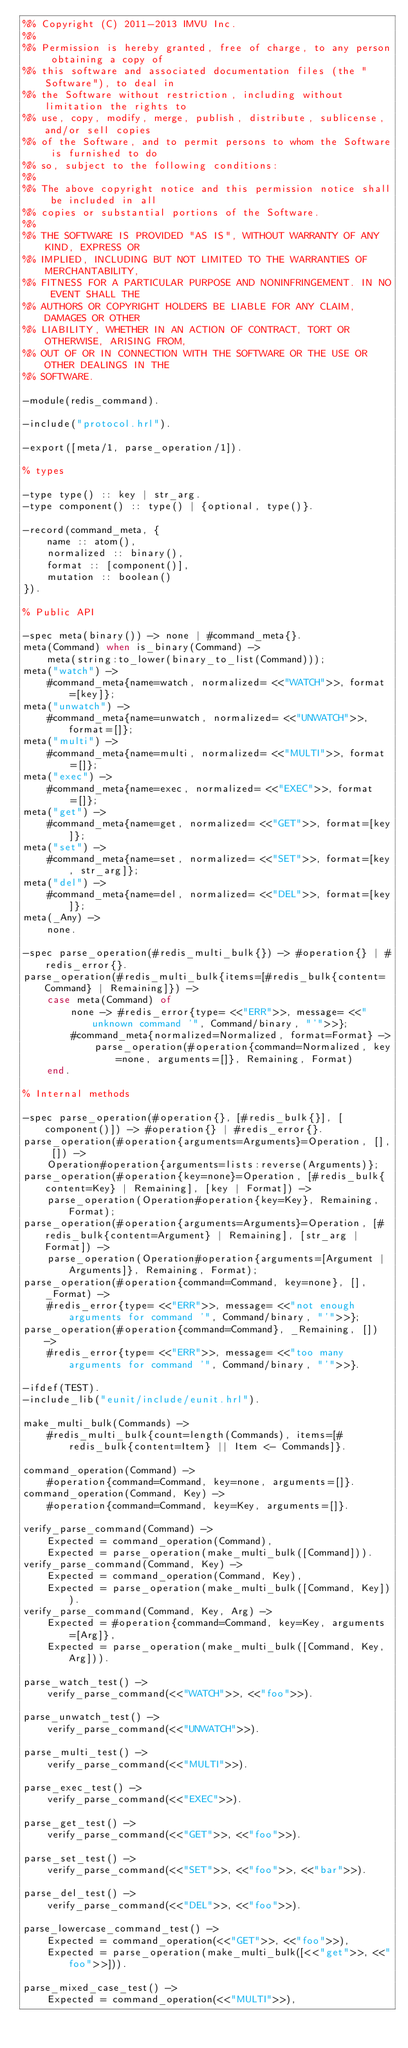Convert code to text. <code><loc_0><loc_0><loc_500><loc_500><_Erlang_>%% Copyright (C) 2011-2013 IMVU Inc.
%%
%% Permission is hereby granted, free of charge, to any person obtaining a copy of
%% this software and associated documentation files (the "Software"), to deal in
%% the Software without restriction, including without limitation the rights to
%% use, copy, modify, merge, publish, distribute, sublicense, and/or sell copies
%% of the Software, and to permit persons to whom the Software is furnished to do
%% so, subject to the following conditions:
%%
%% The above copyright notice and this permission notice shall be included in all
%% copies or substantial portions of the Software.
%%
%% THE SOFTWARE IS PROVIDED "AS IS", WITHOUT WARRANTY OF ANY KIND, EXPRESS OR
%% IMPLIED, INCLUDING BUT NOT LIMITED TO THE WARRANTIES OF MERCHANTABILITY,
%% FITNESS FOR A PARTICULAR PURPOSE AND NONINFRINGEMENT. IN NO EVENT SHALL THE
%% AUTHORS OR COPYRIGHT HOLDERS BE LIABLE FOR ANY CLAIM, DAMAGES OR OTHER
%% LIABILITY, WHETHER IN AN ACTION OF CONTRACT, TORT OR OTHERWISE, ARISING FROM,
%% OUT OF OR IN CONNECTION WITH THE SOFTWARE OR THE USE OR OTHER DEALINGS IN THE
%% SOFTWARE.

-module(redis_command).

-include("protocol.hrl").

-export([meta/1, parse_operation/1]).

% types

-type type() :: key | str_arg.
-type component() :: type() | {optional, type()}.

-record(command_meta, {
    name :: atom(),
    normalized :: binary(),
    format :: [component()],
    mutation :: boolean()
}).

% Public API

-spec meta(binary()) -> none | #command_meta{}.
meta(Command) when is_binary(Command) ->
    meta(string:to_lower(binary_to_list(Command)));
meta("watch") ->
    #command_meta{name=watch, normalized= <<"WATCH">>, format=[key]};
meta("unwatch") ->
    #command_meta{name=unwatch, normalized= <<"UNWATCH">>, format=[]};
meta("multi") ->
    #command_meta{name=multi, normalized= <<"MULTI">>, format=[]};
meta("exec") ->
    #command_meta{name=exec, normalized= <<"EXEC">>, format=[]};
meta("get") ->
    #command_meta{name=get, normalized= <<"GET">>, format=[key]};
meta("set") ->
    #command_meta{name=set, normalized= <<"SET">>, format=[key, str_arg]};
meta("del") ->
    #command_meta{name=del, normalized= <<"DEL">>, format=[key]};
meta(_Any) ->
    none.

-spec parse_operation(#redis_multi_bulk{}) -> #operation{} | #redis_error{}.
parse_operation(#redis_multi_bulk{items=[#redis_bulk{content=Command} | Remaining]}) ->
    case meta(Command) of
        none -> #redis_error{type= <<"ERR">>, message= <<"unknown command '", Command/binary, "'">>};
        #command_meta{normalized=Normalized, format=Format} ->
            parse_operation(#operation{command=Normalized, key=none, arguments=[]}, Remaining, Format)
    end.

% Internal methods

-spec parse_operation(#operation{}, [#redis_bulk{}], [component()]) -> #operation{} | #redis_error{}.
parse_operation(#operation{arguments=Arguments}=Operation, [], []) ->
    Operation#operation{arguments=lists:reverse(Arguments)};
parse_operation(#operation{key=none}=Operation, [#redis_bulk{content=Key} | Remaining], [key | Format]) ->
    parse_operation(Operation#operation{key=Key}, Remaining, Format);
parse_operation(#operation{arguments=Arguments}=Operation, [#redis_bulk{content=Argument} | Remaining], [str_arg | Format]) ->
    parse_operation(Operation#operation{arguments=[Argument | Arguments]}, Remaining, Format);
parse_operation(#operation{command=Command, key=none}, [], _Format) ->
    #redis_error{type= <<"ERR">>, message= <<"not enough arguments for command '", Command/binary, "'">>};
parse_operation(#operation{command=Command}, _Remaining, []) ->
    #redis_error{type= <<"ERR">>, message= <<"too many arguments for command '", Command/binary, "'">>}.

-ifdef(TEST).
-include_lib("eunit/include/eunit.hrl").

make_multi_bulk(Commands) ->
    #redis_multi_bulk{count=length(Commands), items=[#redis_bulk{content=Item} || Item <- Commands]}.

command_operation(Command) ->
    #operation{command=Command, key=none, arguments=[]}.
command_operation(Command, Key) ->
    #operation{command=Command, key=Key, arguments=[]}.

verify_parse_command(Command) ->
    Expected = command_operation(Command),
    Expected = parse_operation(make_multi_bulk([Command])).
verify_parse_command(Command, Key) ->
    Expected = command_operation(Command, Key),
    Expected = parse_operation(make_multi_bulk([Command, Key])).
verify_parse_command(Command, Key, Arg) ->
    Expected = #operation{command=Command, key=Key, arguments=[Arg]},
    Expected = parse_operation(make_multi_bulk([Command, Key, Arg])).

parse_watch_test() ->
    verify_parse_command(<<"WATCH">>, <<"foo">>).

parse_unwatch_test() ->
    verify_parse_command(<<"UNWATCH">>).

parse_multi_test() ->
    verify_parse_command(<<"MULTI">>).

parse_exec_test() ->
    verify_parse_command(<<"EXEC">>).

parse_get_test() ->
    verify_parse_command(<<"GET">>, <<"foo">>).

parse_set_test() ->
    verify_parse_command(<<"SET">>, <<"foo">>, <<"bar">>).

parse_del_test() ->
    verify_parse_command(<<"DEL">>, <<"foo">>).

parse_lowercase_command_test() ->
    Expected = command_operation(<<"GET">>, <<"foo">>),
    Expected = parse_operation(make_multi_bulk([<<"get">>, <<"foo">>])).

parse_mixed_case_test() ->
    Expected = command_operation(<<"MULTI">>),</code> 